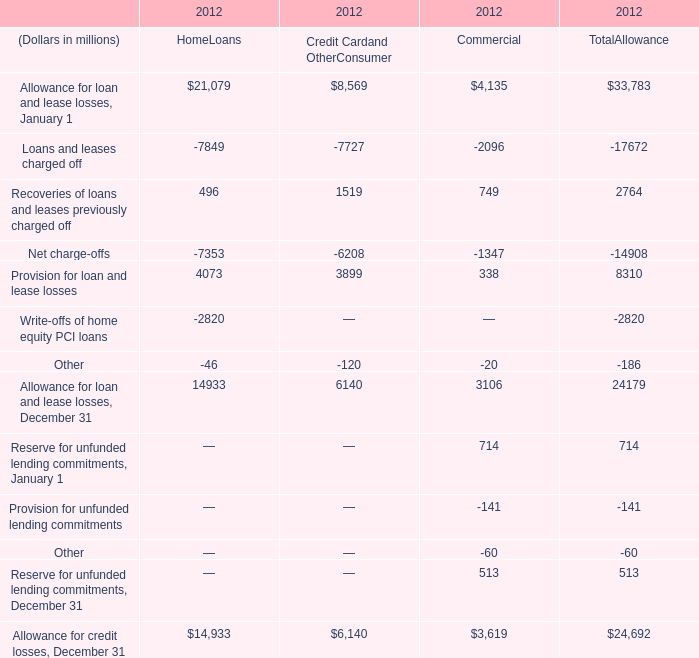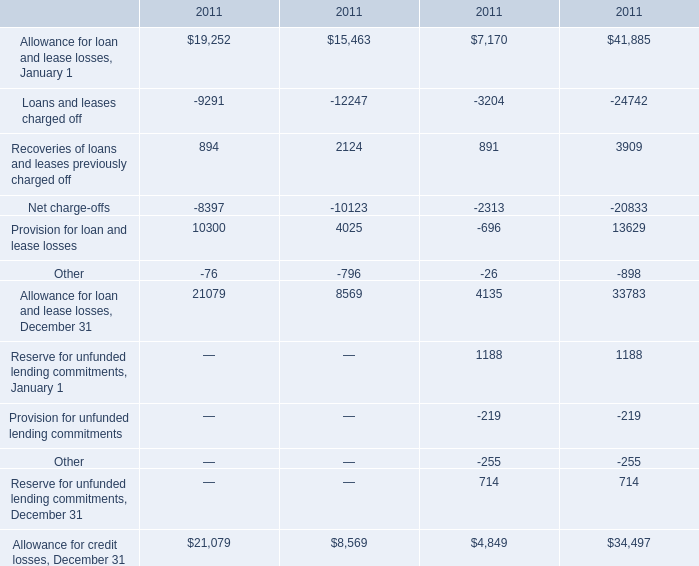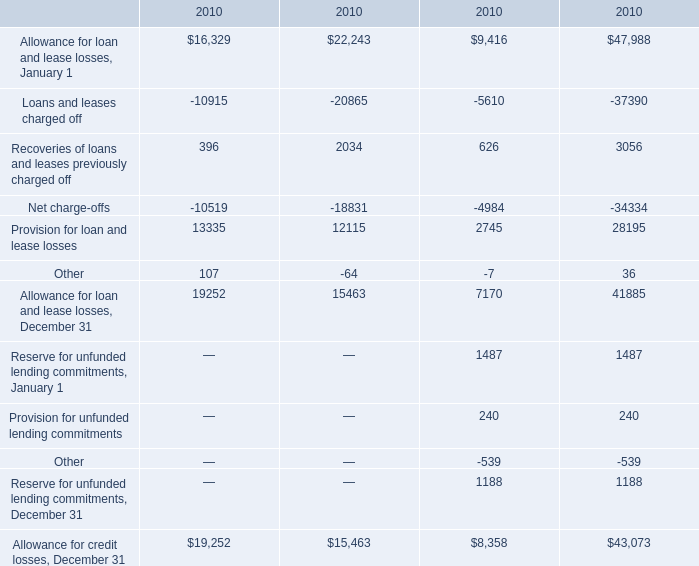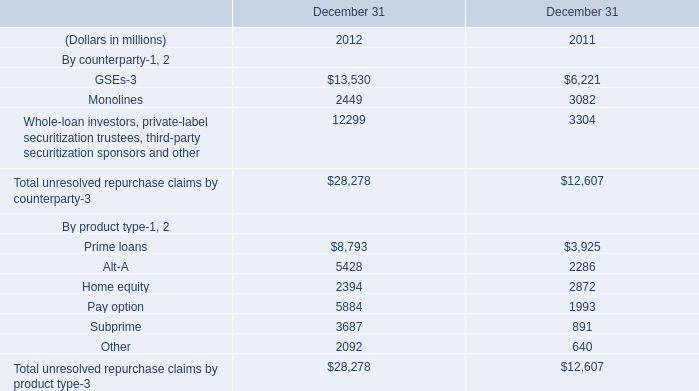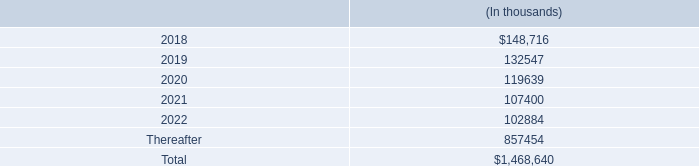How many Provision for loan and lease losses exceed the average of Provision for loan and lease losses in 2011? 
Answer: 2. 